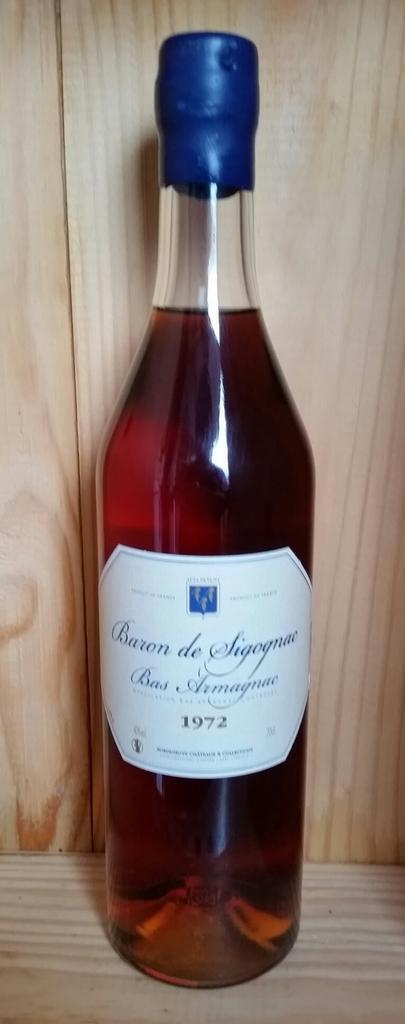What object can be seen in the image? There is a bottle in the image. What type of music is being played from the bottle in the image? There is no music being played from the bottle in the image, as it is just an object and not a source of sound. 